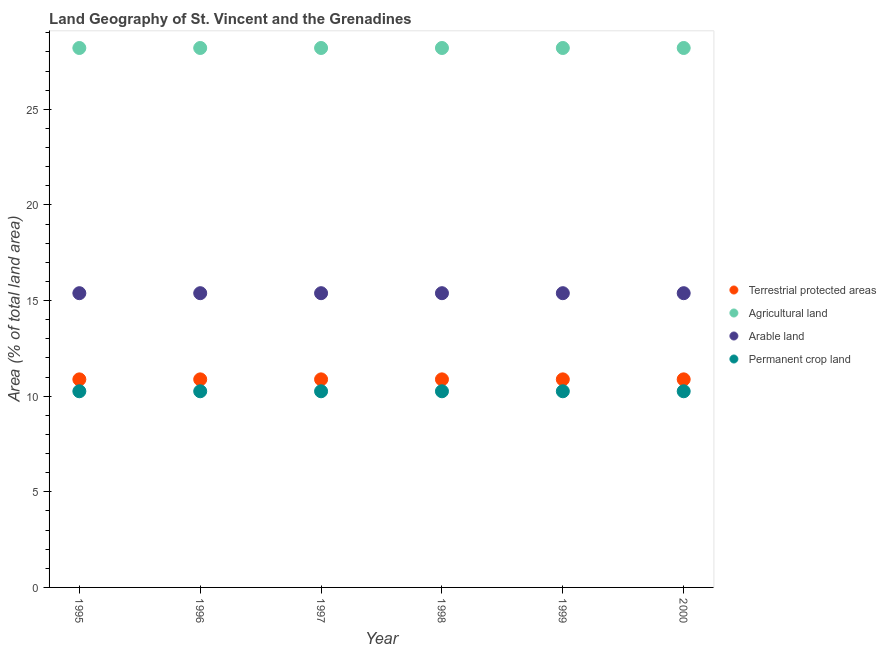What is the percentage of area under arable land in 1997?
Ensure brevity in your answer.  15.38. Across all years, what is the maximum percentage of area under permanent crop land?
Give a very brief answer. 10.26. Across all years, what is the minimum percentage of area under arable land?
Offer a terse response. 15.38. What is the total percentage of area under permanent crop land in the graph?
Provide a short and direct response. 61.54. What is the difference between the percentage of area under permanent crop land in 2000 and the percentage of area under agricultural land in 1996?
Provide a short and direct response. -17.95. What is the average percentage of area under agricultural land per year?
Give a very brief answer. 28.21. In the year 1998, what is the difference between the percentage of area under agricultural land and percentage of land under terrestrial protection?
Offer a very short reply. 17.33. What is the ratio of the percentage of land under terrestrial protection in 1996 to that in 1998?
Provide a succinct answer. 1. Is the difference between the percentage of land under terrestrial protection in 1999 and 2000 greater than the difference between the percentage of area under permanent crop land in 1999 and 2000?
Your answer should be very brief. No. What is the difference between the highest and the second highest percentage of area under agricultural land?
Offer a very short reply. 0. What is the difference between the highest and the lowest percentage of area under arable land?
Keep it short and to the point. 0. In how many years, is the percentage of area under permanent crop land greater than the average percentage of area under permanent crop land taken over all years?
Offer a terse response. 0. Is it the case that in every year, the sum of the percentage of area under arable land and percentage of area under permanent crop land is greater than the sum of percentage of area under agricultural land and percentage of land under terrestrial protection?
Ensure brevity in your answer.  Yes. Does the percentage of area under arable land monotonically increase over the years?
Make the answer very short. No. Are the values on the major ticks of Y-axis written in scientific E-notation?
Your answer should be very brief. No. Does the graph contain any zero values?
Ensure brevity in your answer.  No. Does the graph contain grids?
Your answer should be very brief. No. Where does the legend appear in the graph?
Make the answer very short. Center right. How many legend labels are there?
Your response must be concise. 4. How are the legend labels stacked?
Keep it short and to the point. Vertical. What is the title of the graph?
Provide a succinct answer. Land Geography of St. Vincent and the Grenadines. Does "Natural Gas" appear as one of the legend labels in the graph?
Make the answer very short. No. What is the label or title of the X-axis?
Give a very brief answer. Year. What is the label or title of the Y-axis?
Offer a terse response. Area (% of total land area). What is the Area (% of total land area) of Terrestrial protected areas in 1995?
Ensure brevity in your answer.  10.88. What is the Area (% of total land area) in Agricultural land in 1995?
Provide a succinct answer. 28.21. What is the Area (% of total land area) of Arable land in 1995?
Offer a very short reply. 15.38. What is the Area (% of total land area) in Permanent crop land in 1995?
Your answer should be compact. 10.26. What is the Area (% of total land area) in Terrestrial protected areas in 1996?
Keep it short and to the point. 10.88. What is the Area (% of total land area) of Agricultural land in 1996?
Ensure brevity in your answer.  28.21. What is the Area (% of total land area) in Arable land in 1996?
Offer a terse response. 15.38. What is the Area (% of total land area) of Permanent crop land in 1996?
Ensure brevity in your answer.  10.26. What is the Area (% of total land area) of Terrestrial protected areas in 1997?
Provide a short and direct response. 10.88. What is the Area (% of total land area) in Agricultural land in 1997?
Keep it short and to the point. 28.21. What is the Area (% of total land area) of Arable land in 1997?
Your answer should be compact. 15.38. What is the Area (% of total land area) of Permanent crop land in 1997?
Offer a very short reply. 10.26. What is the Area (% of total land area) in Terrestrial protected areas in 1998?
Your response must be concise. 10.88. What is the Area (% of total land area) in Agricultural land in 1998?
Your answer should be very brief. 28.21. What is the Area (% of total land area) of Arable land in 1998?
Your response must be concise. 15.38. What is the Area (% of total land area) of Permanent crop land in 1998?
Your answer should be compact. 10.26. What is the Area (% of total land area) in Terrestrial protected areas in 1999?
Offer a terse response. 10.88. What is the Area (% of total land area) in Agricultural land in 1999?
Keep it short and to the point. 28.21. What is the Area (% of total land area) in Arable land in 1999?
Make the answer very short. 15.38. What is the Area (% of total land area) in Permanent crop land in 1999?
Offer a terse response. 10.26. What is the Area (% of total land area) in Terrestrial protected areas in 2000?
Provide a short and direct response. 10.88. What is the Area (% of total land area) in Agricultural land in 2000?
Ensure brevity in your answer.  28.21. What is the Area (% of total land area) in Arable land in 2000?
Provide a succinct answer. 15.38. What is the Area (% of total land area) in Permanent crop land in 2000?
Make the answer very short. 10.26. Across all years, what is the maximum Area (% of total land area) in Terrestrial protected areas?
Provide a short and direct response. 10.88. Across all years, what is the maximum Area (% of total land area) of Agricultural land?
Provide a succinct answer. 28.21. Across all years, what is the maximum Area (% of total land area) in Arable land?
Give a very brief answer. 15.38. Across all years, what is the maximum Area (% of total land area) in Permanent crop land?
Your response must be concise. 10.26. Across all years, what is the minimum Area (% of total land area) of Terrestrial protected areas?
Offer a terse response. 10.88. Across all years, what is the minimum Area (% of total land area) in Agricultural land?
Your answer should be very brief. 28.21. Across all years, what is the minimum Area (% of total land area) in Arable land?
Provide a succinct answer. 15.38. Across all years, what is the minimum Area (% of total land area) in Permanent crop land?
Give a very brief answer. 10.26. What is the total Area (% of total land area) in Terrestrial protected areas in the graph?
Ensure brevity in your answer.  65.27. What is the total Area (% of total land area) in Agricultural land in the graph?
Your answer should be very brief. 169.23. What is the total Area (% of total land area) in Arable land in the graph?
Your response must be concise. 92.31. What is the total Area (% of total land area) of Permanent crop land in the graph?
Offer a terse response. 61.54. What is the difference between the Area (% of total land area) of Agricultural land in 1995 and that in 1996?
Your answer should be very brief. 0. What is the difference between the Area (% of total land area) in Arable land in 1995 and that in 1996?
Provide a short and direct response. 0. What is the difference between the Area (% of total land area) in Permanent crop land in 1995 and that in 1996?
Provide a short and direct response. 0. What is the difference between the Area (% of total land area) in Terrestrial protected areas in 1995 and that in 1997?
Provide a short and direct response. 0. What is the difference between the Area (% of total land area) in Agricultural land in 1995 and that in 1997?
Your answer should be very brief. 0. What is the difference between the Area (% of total land area) of Arable land in 1995 and that in 1997?
Ensure brevity in your answer.  0. What is the difference between the Area (% of total land area) in Terrestrial protected areas in 1995 and that in 1998?
Your response must be concise. 0. What is the difference between the Area (% of total land area) in Arable land in 1995 and that in 1998?
Keep it short and to the point. 0. What is the difference between the Area (% of total land area) of Permanent crop land in 1995 and that in 1998?
Your answer should be compact. 0. What is the difference between the Area (% of total land area) of Agricultural land in 1995 and that in 1999?
Your response must be concise. 0. What is the difference between the Area (% of total land area) of Terrestrial protected areas in 1995 and that in 2000?
Give a very brief answer. -0. What is the difference between the Area (% of total land area) in Agricultural land in 1995 and that in 2000?
Your answer should be compact. 0. What is the difference between the Area (% of total land area) in Arable land in 1995 and that in 2000?
Offer a terse response. 0. What is the difference between the Area (% of total land area) in Agricultural land in 1996 and that in 1997?
Offer a terse response. 0. What is the difference between the Area (% of total land area) of Terrestrial protected areas in 1996 and that in 1998?
Your response must be concise. 0. What is the difference between the Area (% of total land area) of Agricultural land in 1996 and that in 1999?
Give a very brief answer. 0. What is the difference between the Area (% of total land area) of Arable land in 1996 and that in 1999?
Your answer should be compact. 0. What is the difference between the Area (% of total land area) in Permanent crop land in 1996 and that in 1999?
Make the answer very short. 0. What is the difference between the Area (% of total land area) in Terrestrial protected areas in 1996 and that in 2000?
Give a very brief answer. -0. What is the difference between the Area (% of total land area) of Agricultural land in 1996 and that in 2000?
Offer a very short reply. 0. What is the difference between the Area (% of total land area) of Agricultural land in 1997 and that in 1998?
Provide a short and direct response. 0. What is the difference between the Area (% of total land area) of Permanent crop land in 1997 and that in 1998?
Your answer should be compact. 0. What is the difference between the Area (% of total land area) of Terrestrial protected areas in 1997 and that in 1999?
Your answer should be very brief. 0. What is the difference between the Area (% of total land area) in Agricultural land in 1997 and that in 1999?
Offer a terse response. 0. What is the difference between the Area (% of total land area) of Permanent crop land in 1997 and that in 1999?
Keep it short and to the point. 0. What is the difference between the Area (% of total land area) in Terrestrial protected areas in 1997 and that in 2000?
Give a very brief answer. -0. What is the difference between the Area (% of total land area) of Agricultural land in 1997 and that in 2000?
Keep it short and to the point. 0. What is the difference between the Area (% of total land area) in Permanent crop land in 1997 and that in 2000?
Your answer should be very brief. 0. What is the difference between the Area (% of total land area) of Agricultural land in 1998 and that in 1999?
Offer a very short reply. 0. What is the difference between the Area (% of total land area) in Arable land in 1998 and that in 1999?
Your answer should be compact. 0. What is the difference between the Area (% of total land area) in Terrestrial protected areas in 1998 and that in 2000?
Offer a terse response. -0. What is the difference between the Area (% of total land area) of Agricultural land in 1998 and that in 2000?
Ensure brevity in your answer.  0. What is the difference between the Area (% of total land area) of Arable land in 1998 and that in 2000?
Keep it short and to the point. 0. What is the difference between the Area (% of total land area) of Terrestrial protected areas in 1999 and that in 2000?
Offer a terse response. -0. What is the difference between the Area (% of total land area) in Permanent crop land in 1999 and that in 2000?
Provide a short and direct response. 0. What is the difference between the Area (% of total land area) of Terrestrial protected areas in 1995 and the Area (% of total land area) of Agricultural land in 1996?
Offer a terse response. -17.33. What is the difference between the Area (% of total land area) in Terrestrial protected areas in 1995 and the Area (% of total land area) in Arable land in 1996?
Offer a very short reply. -4.51. What is the difference between the Area (% of total land area) of Terrestrial protected areas in 1995 and the Area (% of total land area) of Permanent crop land in 1996?
Provide a succinct answer. 0.62. What is the difference between the Area (% of total land area) in Agricultural land in 1995 and the Area (% of total land area) in Arable land in 1996?
Your answer should be compact. 12.82. What is the difference between the Area (% of total land area) of Agricultural land in 1995 and the Area (% of total land area) of Permanent crop land in 1996?
Keep it short and to the point. 17.95. What is the difference between the Area (% of total land area) in Arable land in 1995 and the Area (% of total land area) in Permanent crop land in 1996?
Offer a terse response. 5.13. What is the difference between the Area (% of total land area) in Terrestrial protected areas in 1995 and the Area (% of total land area) in Agricultural land in 1997?
Make the answer very short. -17.33. What is the difference between the Area (% of total land area) of Terrestrial protected areas in 1995 and the Area (% of total land area) of Arable land in 1997?
Keep it short and to the point. -4.51. What is the difference between the Area (% of total land area) of Terrestrial protected areas in 1995 and the Area (% of total land area) of Permanent crop land in 1997?
Provide a succinct answer. 0.62. What is the difference between the Area (% of total land area) of Agricultural land in 1995 and the Area (% of total land area) of Arable land in 1997?
Keep it short and to the point. 12.82. What is the difference between the Area (% of total land area) of Agricultural land in 1995 and the Area (% of total land area) of Permanent crop land in 1997?
Offer a very short reply. 17.95. What is the difference between the Area (% of total land area) of Arable land in 1995 and the Area (% of total land area) of Permanent crop land in 1997?
Your answer should be compact. 5.13. What is the difference between the Area (% of total land area) in Terrestrial protected areas in 1995 and the Area (% of total land area) in Agricultural land in 1998?
Offer a terse response. -17.33. What is the difference between the Area (% of total land area) in Terrestrial protected areas in 1995 and the Area (% of total land area) in Arable land in 1998?
Offer a terse response. -4.51. What is the difference between the Area (% of total land area) in Terrestrial protected areas in 1995 and the Area (% of total land area) in Permanent crop land in 1998?
Offer a terse response. 0.62. What is the difference between the Area (% of total land area) of Agricultural land in 1995 and the Area (% of total land area) of Arable land in 1998?
Offer a very short reply. 12.82. What is the difference between the Area (% of total land area) of Agricultural land in 1995 and the Area (% of total land area) of Permanent crop land in 1998?
Provide a short and direct response. 17.95. What is the difference between the Area (% of total land area) in Arable land in 1995 and the Area (% of total land area) in Permanent crop land in 1998?
Your response must be concise. 5.13. What is the difference between the Area (% of total land area) of Terrestrial protected areas in 1995 and the Area (% of total land area) of Agricultural land in 1999?
Offer a terse response. -17.33. What is the difference between the Area (% of total land area) of Terrestrial protected areas in 1995 and the Area (% of total land area) of Arable land in 1999?
Provide a short and direct response. -4.51. What is the difference between the Area (% of total land area) of Terrestrial protected areas in 1995 and the Area (% of total land area) of Permanent crop land in 1999?
Provide a short and direct response. 0.62. What is the difference between the Area (% of total land area) of Agricultural land in 1995 and the Area (% of total land area) of Arable land in 1999?
Your response must be concise. 12.82. What is the difference between the Area (% of total land area) in Agricultural land in 1995 and the Area (% of total land area) in Permanent crop land in 1999?
Keep it short and to the point. 17.95. What is the difference between the Area (% of total land area) in Arable land in 1995 and the Area (% of total land area) in Permanent crop land in 1999?
Keep it short and to the point. 5.13. What is the difference between the Area (% of total land area) of Terrestrial protected areas in 1995 and the Area (% of total land area) of Agricultural land in 2000?
Provide a short and direct response. -17.33. What is the difference between the Area (% of total land area) of Terrestrial protected areas in 1995 and the Area (% of total land area) of Arable land in 2000?
Keep it short and to the point. -4.51. What is the difference between the Area (% of total land area) of Terrestrial protected areas in 1995 and the Area (% of total land area) of Permanent crop land in 2000?
Offer a terse response. 0.62. What is the difference between the Area (% of total land area) in Agricultural land in 1995 and the Area (% of total land area) in Arable land in 2000?
Make the answer very short. 12.82. What is the difference between the Area (% of total land area) in Agricultural land in 1995 and the Area (% of total land area) in Permanent crop land in 2000?
Your answer should be very brief. 17.95. What is the difference between the Area (% of total land area) in Arable land in 1995 and the Area (% of total land area) in Permanent crop land in 2000?
Your answer should be very brief. 5.13. What is the difference between the Area (% of total land area) in Terrestrial protected areas in 1996 and the Area (% of total land area) in Agricultural land in 1997?
Keep it short and to the point. -17.33. What is the difference between the Area (% of total land area) in Terrestrial protected areas in 1996 and the Area (% of total land area) in Arable land in 1997?
Your answer should be compact. -4.51. What is the difference between the Area (% of total land area) of Terrestrial protected areas in 1996 and the Area (% of total land area) of Permanent crop land in 1997?
Give a very brief answer. 0.62. What is the difference between the Area (% of total land area) of Agricultural land in 1996 and the Area (% of total land area) of Arable land in 1997?
Your response must be concise. 12.82. What is the difference between the Area (% of total land area) in Agricultural land in 1996 and the Area (% of total land area) in Permanent crop land in 1997?
Your answer should be compact. 17.95. What is the difference between the Area (% of total land area) in Arable land in 1996 and the Area (% of total land area) in Permanent crop land in 1997?
Provide a succinct answer. 5.13. What is the difference between the Area (% of total land area) in Terrestrial protected areas in 1996 and the Area (% of total land area) in Agricultural land in 1998?
Your response must be concise. -17.33. What is the difference between the Area (% of total land area) of Terrestrial protected areas in 1996 and the Area (% of total land area) of Arable land in 1998?
Offer a very short reply. -4.51. What is the difference between the Area (% of total land area) in Terrestrial protected areas in 1996 and the Area (% of total land area) in Permanent crop land in 1998?
Provide a succinct answer. 0.62. What is the difference between the Area (% of total land area) in Agricultural land in 1996 and the Area (% of total land area) in Arable land in 1998?
Make the answer very short. 12.82. What is the difference between the Area (% of total land area) in Agricultural land in 1996 and the Area (% of total land area) in Permanent crop land in 1998?
Offer a very short reply. 17.95. What is the difference between the Area (% of total land area) in Arable land in 1996 and the Area (% of total land area) in Permanent crop land in 1998?
Make the answer very short. 5.13. What is the difference between the Area (% of total land area) in Terrestrial protected areas in 1996 and the Area (% of total land area) in Agricultural land in 1999?
Your answer should be very brief. -17.33. What is the difference between the Area (% of total land area) in Terrestrial protected areas in 1996 and the Area (% of total land area) in Arable land in 1999?
Your answer should be very brief. -4.51. What is the difference between the Area (% of total land area) of Terrestrial protected areas in 1996 and the Area (% of total land area) of Permanent crop land in 1999?
Ensure brevity in your answer.  0.62. What is the difference between the Area (% of total land area) in Agricultural land in 1996 and the Area (% of total land area) in Arable land in 1999?
Your answer should be very brief. 12.82. What is the difference between the Area (% of total land area) of Agricultural land in 1996 and the Area (% of total land area) of Permanent crop land in 1999?
Offer a terse response. 17.95. What is the difference between the Area (% of total land area) in Arable land in 1996 and the Area (% of total land area) in Permanent crop land in 1999?
Your answer should be compact. 5.13. What is the difference between the Area (% of total land area) of Terrestrial protected areas in 1996 and the Area (% of total land area) of Agricultural land in 2000?
Provide a succinct answer. -17.33. What is the difference between the Area (% of total land area) of Terrestrial protected areas in 1996 and the Area (% of total land area) of Arable land in 2000?
Keep it short and to the point. -4.51. What is the difference between the Area (% of total land area) in Terrestrial protected areas in 1996 and the Area (% of total land area) in Permanent crop land in 2000?
Offer a terse response. 0.62. What is the difference between the Area (% of total land area) in Agricultural land in 1996 and the Area (% of total land area) in Arable land in 2000?
Make the answer very short. 12.82. What is the difference between the Area (% of total land area) in Agricultural land in 1996 and the Area (% of total land area) in Permanent crop land in 2000?
Provide a succinct answer. 17.95. What is the difference between the Area (% of total land area) of Arable land in 1996 and the Area (% of total land area) of Permanent crop land in 2000?
Ensure brevity in your answer.  5.13. What is the difference between the Area (% of total land area) of Terrestrial protected areas in 1997 and the Area (% of total land area) of Agricultural land in 1998?
Offer a very short reply. -17.33. What is the difference between the Area (% of total land area) of Terrestrial protected areas in 1997 and the Area (% of total land area) of Arable land in 1998?
Your answer should be very brief. -4.51. What is the difference between the Area (% of total land area) in Terrestrial protected areas in 1997 and the Area (% of total land area) in Permanent crop land in 1998?
Make the answer very short. 0.62. What is the difference between the Area (% of total land area) in Agricultural land in 1997 and the Area (% of total land area) in Arable land in 1998?
Keep it short and to the point. 12.82. What is the difference between the Area (% of total land area) in Agricultural land in 1997 and the Area (% of total land area) in Permanent crop land in 1998?
Keep it short and to the point. 17.95. What is the difference between the Area (% of total land area) in Arable land in 1997 and the Area (% of total land area) in Permanent crop land in 1998?
Give a very brief answer. 5.13. What is the difference between the Area (% of total land area) of Terrestrial protected areas in 1997 and the Area (% of total land area) of Agricultural land in 1999?
Your answer should be very brief. -17.33. What is the difference between the Area (% of total land area) of Terrestrial protected areas in 1997 and the Area (% of total land area) of Arable land in 1999?
Your answer should be compact. -4.51. What is the difference between the Area (% of total land area) of Terrestrial protected areas in 1997 and the Area (% of total land area) of Permanent crop land in 1999?
Ensure brevity in your answer.  0.62. What is the difference between the Area (% of total land area) of Agricultural land in 1997 and the Area (% of total land area) of Arable land in 1999?
Provide a succinct answer. 12.82. What is the difference between the Area (% of total land area) in Agricultural land in 1997 and the Area (% of total land area) in Permanent crop land in 1999?
Provide a succinct answer. 17.95. What is the difference between the Area (% of total land area) in Arable land in 1997 and the Area (% of total land area) in Permanent crop land in 1999?
Make the answer very short. 5.13. What is the difference between the Area (% of total land area) of Terrestrial protected areas in 1997 and the Area (% of total land area) of Agricultural land in 2000?
Provide a short and direct response. -17.33. What is the difference between the Area (% of total land area) of Terrestrial protected areas in 1997 and the Area (% of total land area) of Arable land in 2000?
Your response must be concise. -4.51. What is the difference between the Area (% of total land area) of Terrestrial protected areas in 1997 and the Area (% of total land area) of Permanent crop land in 2000?
Provide a succinct answer. 0.62. What is the difference between the Area (% of total land area) of Agricultural land in 1997 and the Area (% of total land area) of Arable land in 2000?
Provide a succinct answer. 12.82. What is the difference between the Area (% of total land area) of Agricultural land in 1997 and the Area (% of total land area) of Permanent crop land in 2000?
Your answer should be compact. 17.95. What is the difference between the Area (% of total land area) in Arable land in 1997 and the Area (% of total land area) in Permanent crop land in 2000?
Offer a very short reply. 5.13. What is the difference between the Area (% of total land area) of Terrestrial protected areas in 1998 and the Area (% of total land area) of Agricultural land in 1999?
Ensure brevity in your answer.  -17.33. What is the difference between the Area (% of total land area) in Terrestrial protected areas in 1998 and the Area (% of total land area) in Arable land in 1999?
Offer a terse response. -4.51. What is the difference between the Area (% of total land area) of Terrestrial protected areas in 1998 and the Area (% of total land area) of Permanent crop land in 1999?
Make the answer very short. 0.62. What is the difference between the Area (% of total land area) in Agricultural land in 1998 and the Area (% of total land area) in Arable land in 1999?
Your response must be concise. 12.82. What is the difference between the Area (% of total land area) of Agricultural land in 1998 and the Area (% of total land area) of Permanent crop land in 1999?
Ensure brevity in your answer.  17.95. What is the difference between the Area (% of total land area) in Arable land in 1998 and the Area (% of total land area) in Permanent crop land in 1999?
Offer a very short reply. 5.13. What is the difference between the Area (% of total land area) of Terrestrial protected areas in 1998 and the Area (% of total land area) of Agricultural land in 2000?
Keep it short and to the point. -17.33. What is the difference between the Area (% of total land area) in Terrestrial protected areas in 1998 and the Area (% of total land area) in Arable land in 2000?
Provide a short and direct response. -4.51. What is the difference between the Area (% of total land area) in Terrestrial protected areas in 1998 and the Area (% of total land area) in Permanent crop land in 2000?
Keep it short and to the point. 0.62. What is the difference between the Area (% of total land area) in Agricultural land in 1998 and the Area (% of total land area) in Arable land in 2000?
Provide a short and direct response. 12.82. What is the difference between the Area (% of total land area) in Agricultural land in 1998 and the Area (% of total land area) in Permanent crop land in 2000?
Give a very brief answer. 17.95. What is the difference between the Area (% of total land area) in Arable land in 1998 and the Area (% of total land area) in Permanent crop land in 2000?
Your answer should be compact. 5.13. What is the difference between the Area (% of total land area) in Terrestrial protected areas in 1999 and the Area (% of total land area) in Agricultural land in 2000?
Provide a short and direct response. -17.33. What is the difference between the Area (% of total land area) in Terrestrial protected areas in 1999 and the Area (% of total land area) in Arable land in 2000?
Provide a short and direct response. -4.51. What is the difference between the Area (% of total land area) of Terrestrial protected areas in 1999 and the Area (% of total land area) of Permanent crop land in 2000?
Provide a succinct answer. 0.62. What is the difference between the Area (% of total land area) of Agricultural land in 1999 and the Area (% of total land area) of Arable land in 2000?
Keep it short and to the point. 12.82. What is the difference between the Area (% of total land area) of Agricultural land in 1999 and the Area (% of total land area) of Permanent crop land in 2000?
Offer a very short reply. 17.95. What is the difference between the Area (% of total land area) of Arable land in 1999 and the Area (% of total land area) of Permanent crop land in 2000?
Offer a very short reply. 5.13. What is the average Area (% of total land area) of Terrestrial protected areas per year?
Keep it short and to the point. 10.88. What is the average Area (% of total land area) of Agricultural land per year?
Your answer should be compact. 28.21. What is the average Area (% of total land area) of Arable land per year?
Provide a short and direct response. 15.38. What is the average Area (% of total land area) of Permanent crop land per year?
Your answer should be compact. 10.26. In the year 1995, what is the difference between the Area (% of total land area) in Terrestrial protected areas and Area (% of total land area) in Agricultural land?
Your response must be concise. -17.33. In the year 1995, what is the difference between the Area (% of total land area) in Terrestrial protected areas and Area (% of total land area) in Arable land?
Your response must be concise. -4.51. In the year 1995, what is the difference between the Area (% of total land area) of Terrestrial protected areas and Area (% of total land area) of Permanent crop land?
Give a very brief answer. 0.62. In the year 1995, what is the difference between the Area (% of total land area) of Agricultural land and Area (% of total land area) of Arable land?
Your answer should be compact. 12.82. In the year 1995, what is the difference between the Area (% of total land area) of Agricultural land and Area (% of total land area) of Permanent crop land?
Ensure brevity in your answer.  17.95. In the year 1995, what is the difference between the Area (% of total land area) in Arable land and Area (% of total land area) in Permanent crop land?
Keep it short and to the point. 5.13. In the year 1996, what is the difference between the Area (% of total land area) of Terrestrial protected areas and Area (% of total land area) of Agricultural land?
Your answer should be compact. -17.33. In the year 1996, what is the difference between the Area (% of total land area) of Terrestrial protected areas and Area (% of total land area) of Arable land?
Provide a short and direct response. -4.51. In the year 1996, what is the difference between the Area (% of total land area) in Terrestrial protected areas and Area (% of total land area) in Permanent crop land?
Keep it short and to the point. 0.62. In the year 1996, what is the difference between the Area (% of total land area) of Agricultural land and Area (% of total land area) of Arable land?
Offer a very short reply. 12.82. In the year 1996, what is the difference between the Area (% of total land area) in Agricultural land and Area (% of total land area) in Permanent crop land?
Your answer should be very brief. 17.95. In the year 1996, what is the difference between the Area (% of total land area) in Arable land and Area (% of total land area) in Permanent crop land?
Offer a terse response. 5.13. In the year 1997, what is the difference between the Area (% of total land area) in Terrestrial protected areas and Area (% of total land area) in Agricultural land?
Ensure brevity in your answer.  -17.33. In the year 1997, what is the difference between the Area (% of total land area) of Terrestrial protected areas and Area (% of total land area) of Arable land?
Keep it short and to the point. -4.51. In the year 1997, what is the difference between the Area (% of total land area) of Terrestrial protected areas and Area (% of total land area) of Permanent crop land?
Provide a short and direct response. 0.62. In the year 1997, what is the difference between the Area (% of total land area) of Agricultural land and Area (% of total land area) of Arable land?
Provide a succinct answer. 12.82. In the year 1997, what is the difference between the Area (% of total land area) in Agricultural land and Area (% of total land area) in Permanent crop land?
Your answer should be very brief. 17.95. In the year 1997, what is the difference between the Area (% of total land area) of Arable land and Area (% of total land area) of Permanent crop land?
Your response must be concise. 5.13. In the year 1998, what is the difference between the Area (% of total land area) of Terrestrial protected areas and Area (% of total land area) of Agricultural land?
Offer a terse response. -17.33. In the year 1998, what is the difference between the Area (% of total land area) of Terrestrial protected areas and Area (% of total land area) of Arable land?
Your answer should be compact. -4.51. In the year 1998, what is the difference between the Area (% of total land area) of Terrestrial protected areas and Area (% of total land area) of Permanent crop land?
Provide a short and direct response. 0.62. In the year 1998, what is the difference between the Area (% of total land area) in Agricultural land and Area (% of total land area) in Arable land?
Give a very brief answer. 12.82. In the year 1998, what is the difference between the Area (% of total land area) of Agricultural land and Area (% of total land area) of Permanent crop land?
Provide a short and direct response. 17.95. In the year 1998, what is the difference between the Area (% of total land area) of Arable land and Area (% of total land area) of Permanent crop land?
Your answer should be very brief. 5.13. In the year 1999, what is the difference between the Area (% of total land area) in Terrestrial protected areas and Area (% of total land area) in Agricultural land?
Give a very brief answer. -17.33. In the year 1999, what is the difference between the Area (% of total land area) of Terrestrial protected areas and Area (% of total land area) of Arable land?
Your answer should be very brief. -4.51. In the year 1999, what is the difference between the Area (% of total land area) in Terrestrial protected areas and Area (% of total land area) in Permanent crop land?
Your answer should be compact. 0.62. In the year 1999, what is the difference between the Area (% of total land area) in Agricultural land and Area (% of total land area) in Arable land?
Provide a succinct answer. 12.82. In the year 1999, what is the difference between the Area (% of total land area) of Agricultural land and Area (% of total land area) of Permanent crop land?
Give a very brief answer. 17.95. In the year 1999, what is the difference between the Area (% of total land area) of Arable land and Area (% of total land area) of Permanent crop land?
Your response must be concise. 5.13. In the year 2000, what is the difference between the Area (% of total land area) in Terrestrial protected areas and Area (% of total land area) in Agricultural land?
Provide a short and direct response. -17.33. In the year 2000, what is the difference between the Area (% of total land area) of Terrestrial protected areas and Area (% of total land area) of Arable land?
Provide a short and direct response. -4.51. In the year 2000, what is the difference between the Area (% of total land area) in Terrestrial protected areas and Area (% of total land area) in Permanent crop land?
Offer a very short reply. 0.62. In the year 2000, what is the difference between the Area (% of total land area) in Agricultural land and Area (% of total land area) in Arable land?
Your response must be concise. 12.82. In the year 2000, what is the difference between the Area (% of total land area) in Agricultural land and Area (% of total land area) in Permanent crop land?
Provide a short and direct response. 17.95. In the year 2000, what is the difference between the Area (% of total land area) of Arable land and Area (% of total land area) of Permanent crop land?
Your response must be concise. 5.13. What is the ratio of the Area (% of total land area) in Terrestrial protected areas in 1995 to that in 1996?
Your response must be concise. 1. What is the ratio of the Area (% of total land area) in Agricultural land in 1995 to that in 1996?
Ensure brevity in your answer.  1. What is the ratio of the Area (% of total land area) of Terrestrial protected areas in 1995 to that in 1997?
Offer a very short reply. 1. What is the ratio of the Area (% of total land area) of Agricultural land in 1995 to that in 1997?
Your response must be concise. 1. What is the ratio of the Area (% of total land area) of Arable land in 1995 to that in 1997?
Offer a terse response. 1. What is the ratio of the Area (% of total land area) of Permanent crop land in 1995 to that in 1997?
Your answer should be very brief. 1. What is the ratio of the Area (% of total land area) of Terrestrial protected areas in 1995 to that in 1998?
Provide a short and direct response. 1. What is the ratio of the Area (% of total land area) of Arable land in 1995 to that in 1998?
Give a very brief answer. 1. What is the ratio of the Area (% of total land area) of Terrestrial protected areas in 1995 to that in 1999?
Keep it short and to the point. 1. What is the ratio of the Area (% of total land area) of Agricultural land in 1995 to that in 1999?
Make the answer very short. 1. What is the ratio of the Area (% of total land area) in Permanent crop land in 1995 to that in 1999?
Offer a very short reply. 1. What is the ratio of the Area (% of total land area) of Arable land in 1995 to that in 2000?
Give a very brief answer. 1. What is the ratio of the Area (% of total land area) of Permanent crop land in 1995 to that in 2000?
Your answer should be compact. 1. What is the ratio of the Area (% of total land area) of Agricultural land in 1996 to that in 1998?
Give a very brief answer. 1. What is the ratio of the Area (% of total land area) of Arable land in 1996 to that in 1998?
Provide a succinct answer. 1. What is the ratio of the Area (% of total land area) in Permanent crop land in 1996 to that in 1998?
Ensure brevity in your answer.  1. What is the ratio of the Area (% of total land area) in Agricultural land in 1996 to that in 1999?
Make the answer very short. 1. What is the ratio of the Area (% of total land area) in Agricultural land in 1996 to that in 2000?
Ensure brevity in your answer.  1. What is the ratio of the Area (% of total land area) of Arable land in 1996 to that in 2000?
Provide a succinct answer. 1. What is the ratio of the Area (% of total land area) in Permanent crop land in 1996 to that in 2000?
Your answer should be compact. 1. What is the ratio of the Area (% of total land area) in Permanent crop land in 1997 to that in 1998?
Your response must be concise. 1. What is the ratio of the Area (% of total land area) of Terrestrial protected areas in 1997 to that in 2000?
Offer a terse response. 1. What is the ratio of the Area (% of total land area) of Terrestrial protected areas in 1998 to that in 1999?
Your response must be concise. 1. What is the ratio of the Area (% of total land area) in Arable land in 1998 to that in 1999?
Ensure brevity in your answer.  1. What is the ratio of the Area (% of total land area) of Agricultural land in 1998 to that in 2000?
Your response must be concise. 1. What is the ratio of the Area (% of total land area) in Arable land in 1998 to that in 2000?
Keep it short and to the point. 1. What is the ratio of the Area (% of total land area) of Permanent crop land in 1998 to that in 2000?
Provide a succinct answer. 1. What is the ratio of the Area (% of total land area) in Arable land in 1999 to that in 2000?
Offer a very short reply. 1. What is the ratio of the Area (% of total land area) of Permanent crop land in 1999 to that in 2000?
Ensure brevity in your answer.  1. What is the difference between the highest and the second highest Area (% of total land area) in Arable land?
Offer a very short reply. 0. What is the difference between the highest and the lowest Area (% of total land area) in Terrestrial protected areas?
Keep it short and to the point. 0. What is the difference between the highest and the lowest Area (% of total land area) in Arable land?
Your response must be concise. 0. 